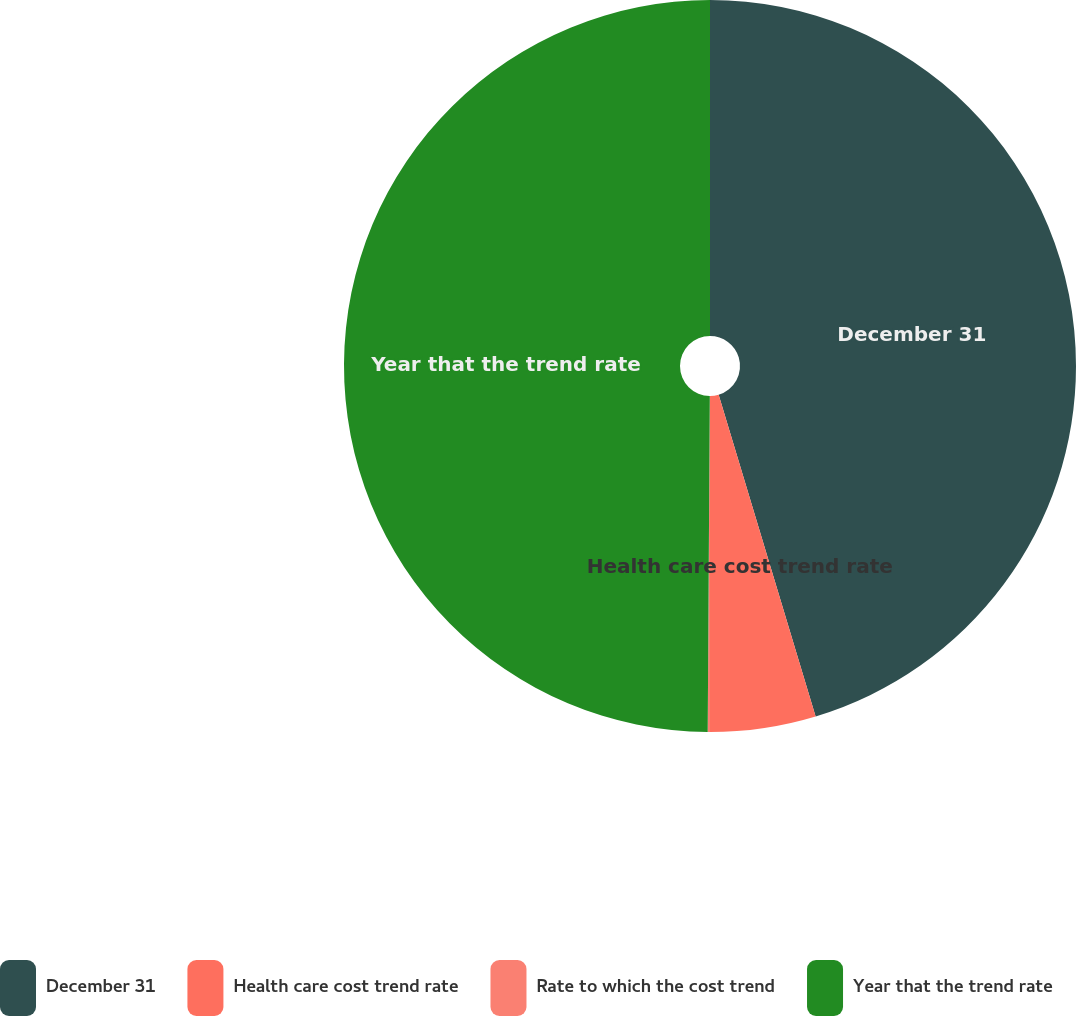<chart> <loc_0><loc_0><loc_500><loc_500><pie_chart><fcel>December 31<fcel>Health care cost trend rate<fcel>Rate to which the cost trend<fcel>Year that the trend rate<nl><fcel>45.34%<fcel>4.66%<fcel>0.1%<fcel>49.9%<nl></chart> 